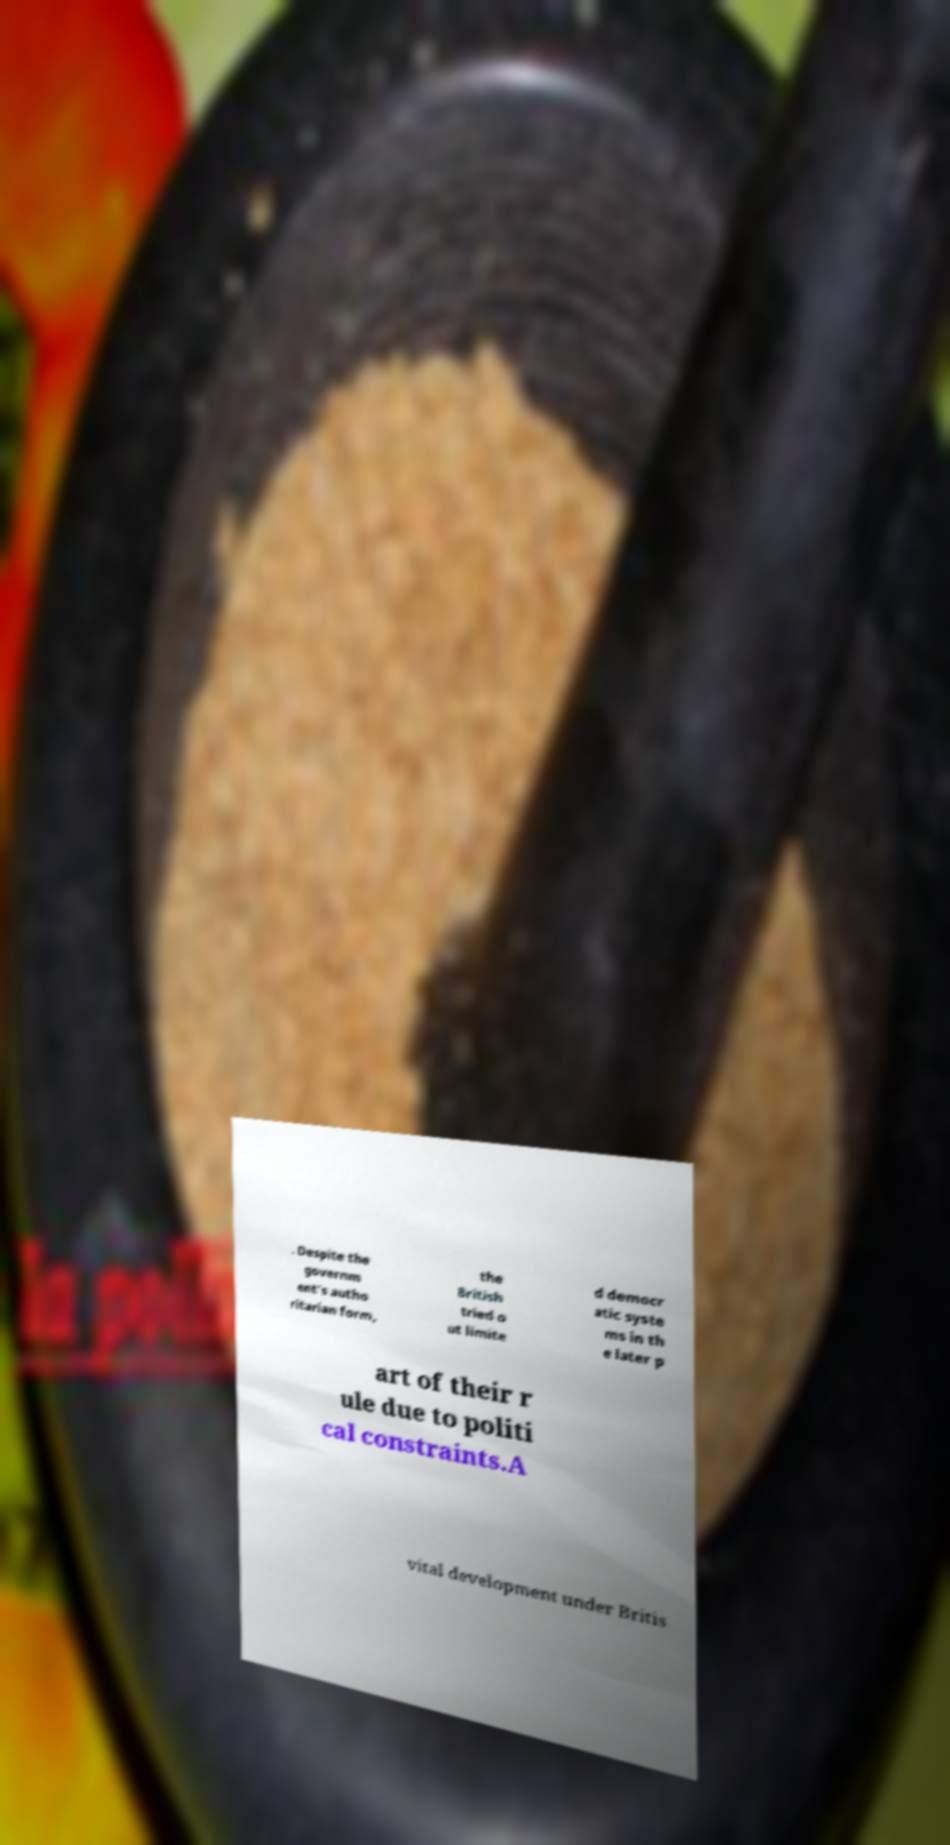There's text embedded in this image that I need extracted. Can you transcribe it verbatim? . Despite the governm ent's autho ritarian form, the British tried o ut limite d democr atic syste ms in th e later p art of their r ule due to politi cal constraints.A vital development under Britis 